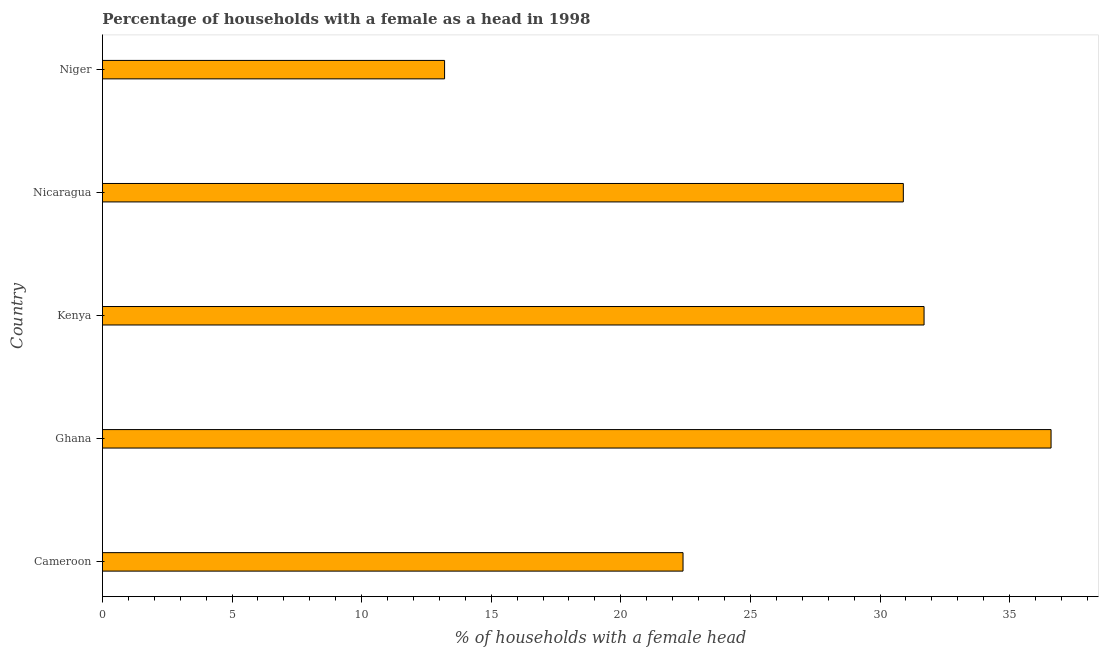What is the title of the graph?
Provide a short and direct response. Percentage of households with a female as a head in 1998. What is the label or title of the X-axis?
Give a very brief answer. % of households with a female head. What is the number of female supervised households in Niger?
Keep it short and to the point. 13.2. Across all countries, what is the maximum number of female supervised households?
Ensure brevity in your answer.  36.6. Across all countries, what is the minimum number of female supervised households?
Make the answer very short. 13.2. In which country was the number of female supervised households maximum?
Provide a succinct answer. Ghana. In which country was the number of female supervised households minimum?
Your answer should be compact. Niger. What is the sum of the number of female supervised households?
Ensure brevity in your answer.  134.8. What is the difference between the number of female supervised households in Cameroon and Nicaragua?
Offer a terse response. -8.5. What is the average number of female supervised households per country?
Keep it short and to the point. 26.96. What is the median number of female supervised households?
Keep it short and to the point. 30.9. What is the ratio of the number of female supervised households in Cameroon to that in Nicaragua?
Your answer should be compact. 0.72. Is the difference between the number of female supervised households in Kenya and Nicaragua greater than the difference between any two countries?
Offer a terse response. No. What is the difference between the highest and the second highest number of female supervised households?
Give a very brief answer. 4.9. What is the difference between the highest and the lowest number of female supervised households?
Provide a short and direct response. 23.4. In how many countries, is the number of female supervised households greater than the average number of female supervised households taken over all countries?
Keep it short and to the point. 3. How many bars are there?
Provide a succinct answer. 5. Are all the bars in the graph horizontal?
Provide a short and direct response. Yes. Are the values on the major ticks of X-axis written in scientific E-notation?
Ensure brevity in your answer.  No. What is the % of households with a female head in Cameroon?
Keep it short and to the point. 22.4. What is the % of households with a female head of Ghana?
Give a very brief answer. 36.6. What is the % of households with a female head of Kenya?
Ensure brevity in your answer.  31.7. What is the % of households with a female head of Nicaragua?
Your answer should be very brief. 30.9. What is the % of households with a female head in Niger?
Provide a short and direct response. 13.2. What is the difference between the % of households with a female head in Ghana and Nicaragua?
Your answer should be very brief. 5.7. What is the difference between the % of households with a female head in Ghana and Niger?
Offer a terse response. 23.4. What is the difference between the % of households with a female head in Kenya and Nicaragua?
Keep it short and to the point. 0.8. What is the difference between the % of households with a female head in Kenya and Niger?
Give a very brief answer. 18.5. What is the difference between the % of households with a female head in Nicaragua and Niger?
Provide a succinct answer. 17.7. What is the ratio of the % of households with a female head in Cameroon to that in Ghana?
Keep it short and to the point. 0.61. What is the ratio of the % of households with a female head in Cameroon to that in Kenya?
Your response must be concise. 0.71. What is the ratio of the % of households with a female head in Cameroon to that in Nicaragua?
Provide a succinct answer. 0.72. What is the ratio of the % of households with a female head in Cameroon to that in Niger?
Ensure brevity in your answer.  1.7. What is the ratio of the % of households with a female head in Ghana to that in Kenya?
Your response must be concise. 1.16. What is the ratio of the % of households with a female head in Ghana to that in Nicaragua?
Your answer should be compact. 1.18. What is the ratio of the % of households with a female head in Ghana to that in Niger?
Ensure brevity in your answer.  2.77. What is the ratio of the % of households with a female head in Kenya to that in Niger?
Ensure brevity in your answer.  2.4. What is the ratio of the % of households with a female head in Nicaragua to that in Niger?
Your answer should be compact. 2.34. 